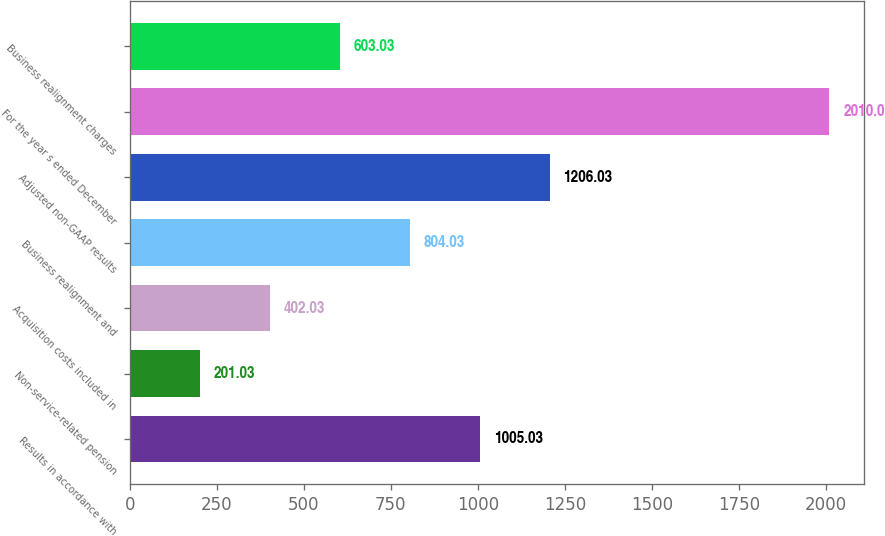Convert chart to OTSL. <chart><loc_0><loc_0><loc_500><loc_500><bar_chart><fcel>Results in accordance with<fcel>Non-service-related pension<fcel>Acquisition costs included in<fcel>Business realignment and<fcel>Adjusted non-GAAP results<fcel>For the year s ended December<fcel>Business realignment charges<nl><fcel>1005.03<fcel>201.03<fcel>402.03<fcel>804.03<fcel>1206.03<fcel>2010<fcel>603.03<nl></chart> 